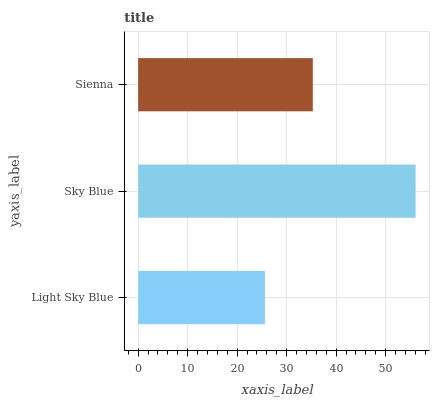Is Light Sky Blue the minimum?
Answer yes or no. Yes. Is Sky Blue the maximum?
Answer yes or no. Yes. Is Sienna the minimum?
Answer yes or no. No. Is Sienna the maximum?
Answer yes or no. No. Is Sky Blue greater than Sienna?
Answer yes or no. Yes. Is Sienna less than Sky Blue?
Answer yes or no. Yes. Is Sienna greater than Sky Blue?
Answer yes or no. No. Is Sky Blue less than Sienna?
Answer yes or no. No. Is Sienna the high median?
Answer yes or no. Yes. Is Sienna the low median?
Answer yes or no. Yes. Is Sky Blue the high median?
Answer yes or no. No. Is Light Sky Blue the low median?
Answer yes or no. No. 